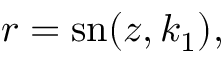<formula> <loc_0><loc_0><loc_500><loc_500>\begin{array} { r } { r = s n ( z , k _ { 1 } ) , } \end{array}</formula> 